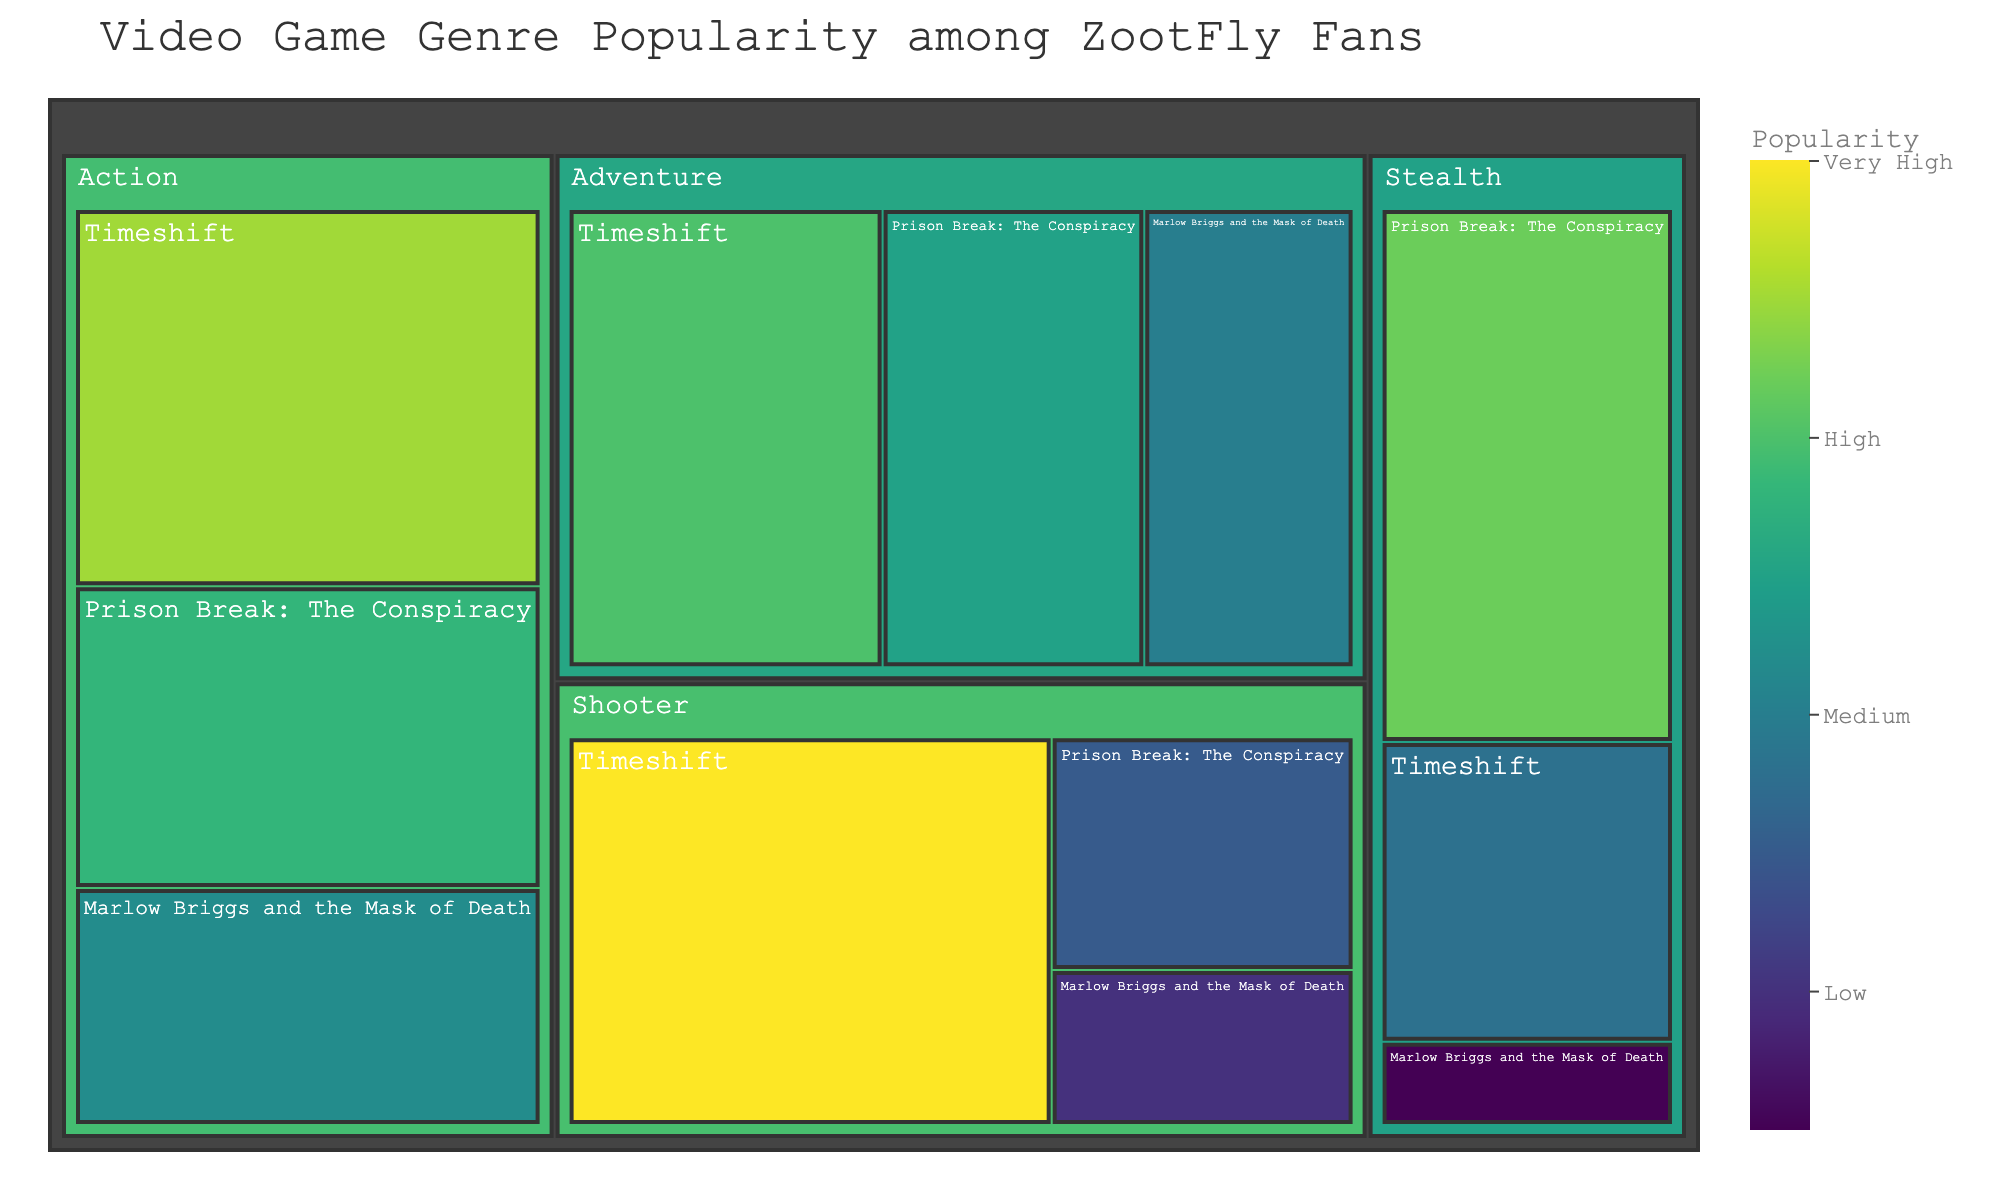What is the title of the treemap? The title of the treemap can be found at the top of the figure.
Answer: Video Game Genre Popularity among ZootFly Fans Which genre has the highest total popularity among ZootFly fans? To find the highest total popularity for a genre, sum the popularity values of all games within each genre. Action: (35 + 28 + 22) = 85, Adventure: (30 + 25 + 20) = 75, Shooter: (40 + 15 + 10) = 65, Stealth: (32 + 18 + 5) = 55. Action has the highest total popularity.
Answer: Action Which game in the Shooter genre is the least popular? Look into the Shooter genre section of the treemap and identify the game with the lowest popularity value.
Answer: Marlow Briggs and the Mask of Death What is the total combined popularity of Timeshift across all genres? Sum the popularity values of Timeshift across all genres: Action (35) + Adventure (30) + Shooter (40) + Stealth (18) = 123
Answer: 123 How much more popular is "Prison Break: The Conspiracy" in the Stealth genre compared to the Shooter genre? Find the popularity of "Prison Break: The Conspiracy" in both genres and subtract the smaller value from the larger value. Stealth: 32, Shooter: 15. The difference is 32 - 15 = 17.
Answer: 17 Which genre contains the game with the highest individual popularity value, and what is that value? Identify the highest individual popularity value from all games and find the corresponding genre. Timeshift in Shooter has the highest value with 40.
Answer: Shooter, 40 How does "Marlow Briggs and the Mask of Death" compare in popularity across the Adventure and Stealth genres? Look at the popularity values of "Marlow Briggs and the Mask of Death" in Adventure and Stealth genres and compare them. Adventure: 20, Stealth: 5.
Answer: More popular in Adventure What is the least popular game among ZootFly fans? Identify the game with the lowest popularity value in the entire treemap. "Marlow Briggs and the Mask of Death" in the Stealth genre has the lowest value of 5.
Answer: Marlow Briggs and the Mask of Death (Stealth) Which genre has the smallest total popularity? Calculate the total popularity for each genre and find the one with the smallest value. Action: 85, Adventure: 75, Shooter: 65, Stealth: 55. Stealth has the smallest total.
Answer: Stealth 